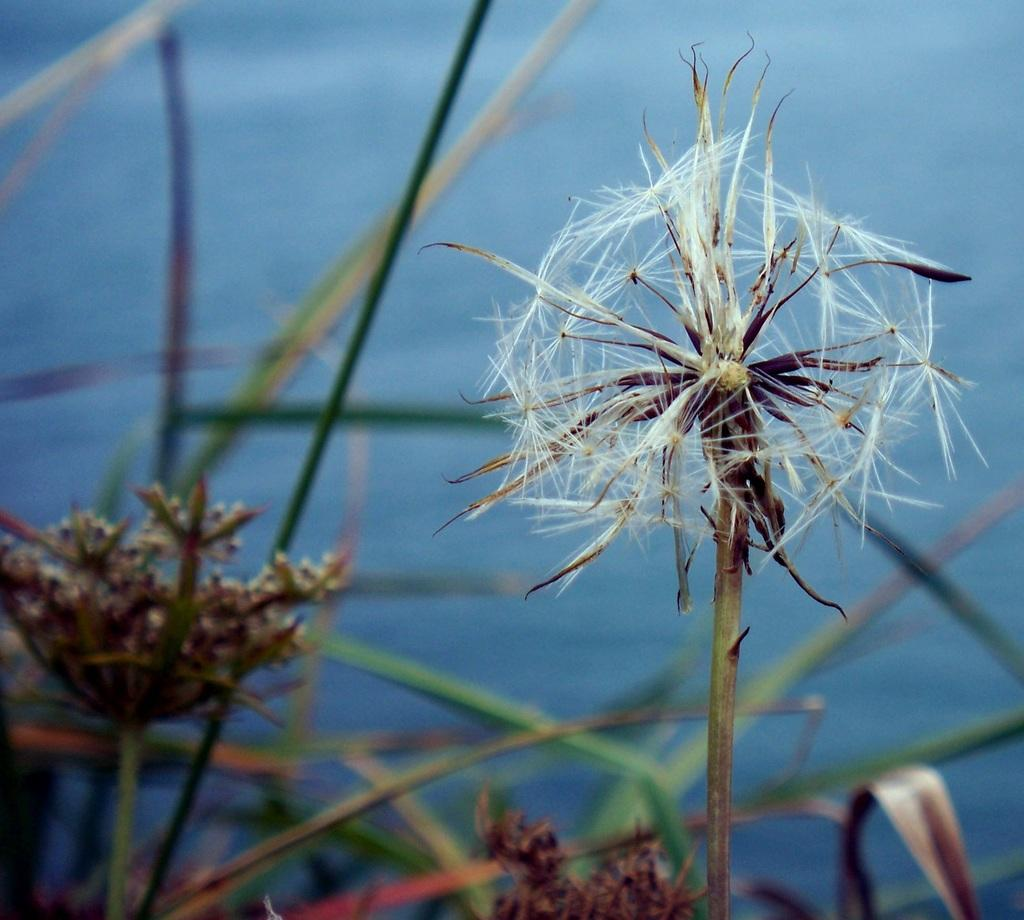What is located at the front of the image? There are flowers in the front of the image. What can be seen in the background of the image? There are objects in the background of the image. What is the color of some of the objects in the background? Some of the objects in the background are green in color, and some are blue in color. What type of cloth is being used to make the soda in the image? There is no cloth or soda present in the image. Is there a tent visible in the image? There is no tent present in the image. 